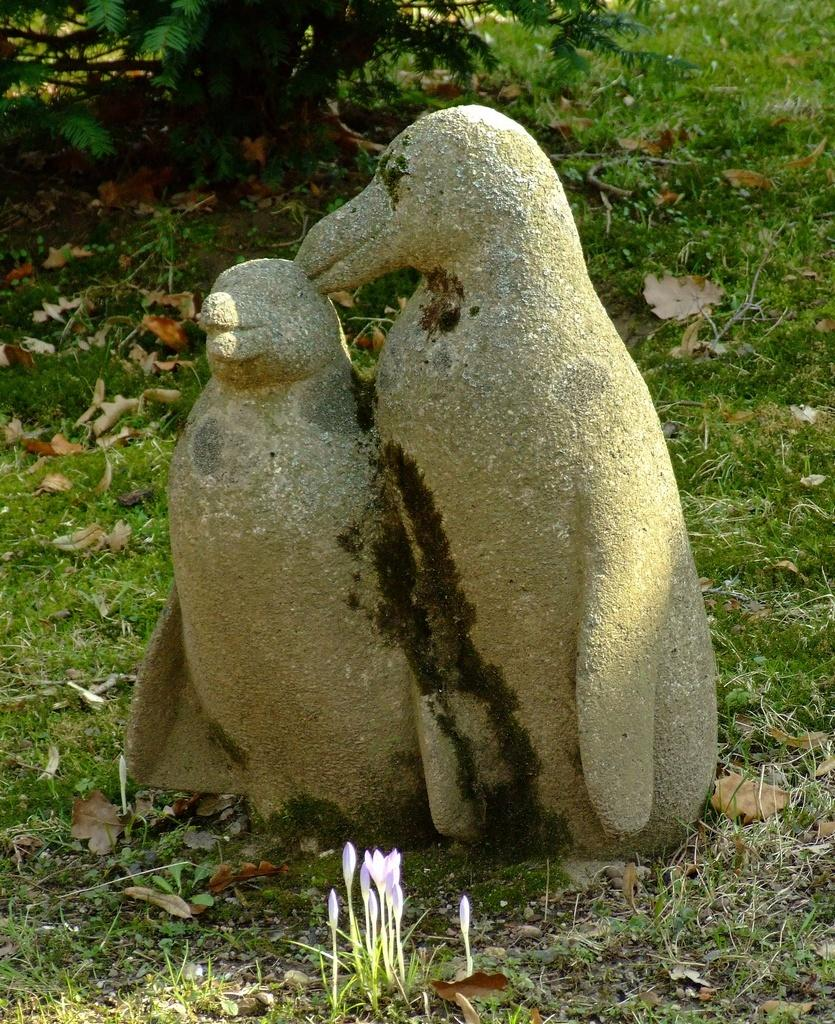What is the main subject in the image? There is a sculpture in the image. What type of natural environment is visible in the image? There is grass, flowers, and a tree in the image. What type of hook can be seen attached to the sculpture in the image? There is no hook present in the image; it features a sculpture surrounded by grass, flowers, and a tree. 